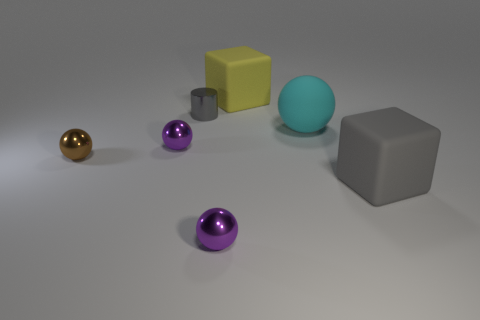There is a shiny thing that is right of the metal cylinder; is it the same color as the rubber block on the left side of the big cyan sphere?
Your answer should be very brief. No. Is the number of red metal things less than the number of large cyan things?
Provide a short and direct response. Yes. There is a small purple metal object in front of the big gray rubber thing on the right side of the cyan thing; what is its shape?
Ensure brevity in your answer.  Sphere. Is there anything else that is the same size as the cyan rubber object?
Provide a short and direct response. Yes. What is the shape of the metal thing that is in front of the gray object to the right of the big matte object that is to the left of the cyan object?
Keep it short and to the point. Sphere. What number of objects are objects that are on the left side of the metal cylinder or big matte objects that are on the left side of the big sphere?
Give a very brief answer. 3. Do the cylinder and the rubber block that is on the right side of the matte sphere have the same size?
Keep it short and to the point. No. Is the large thing that is in front of the brown metal sphere made of the same material as the small purple sphere in front of the tiny brown sphere?
Offer a terse response. No. Are there the same number of big yellow blocks in front of the yellow rubber cube and large gray matte objects that are on the left side of the tiny brown thing?
Your answer should be compact. Yes. What number of shiny balls are the same color as the metal cylinder?
Keep it short and to the point. 0. 